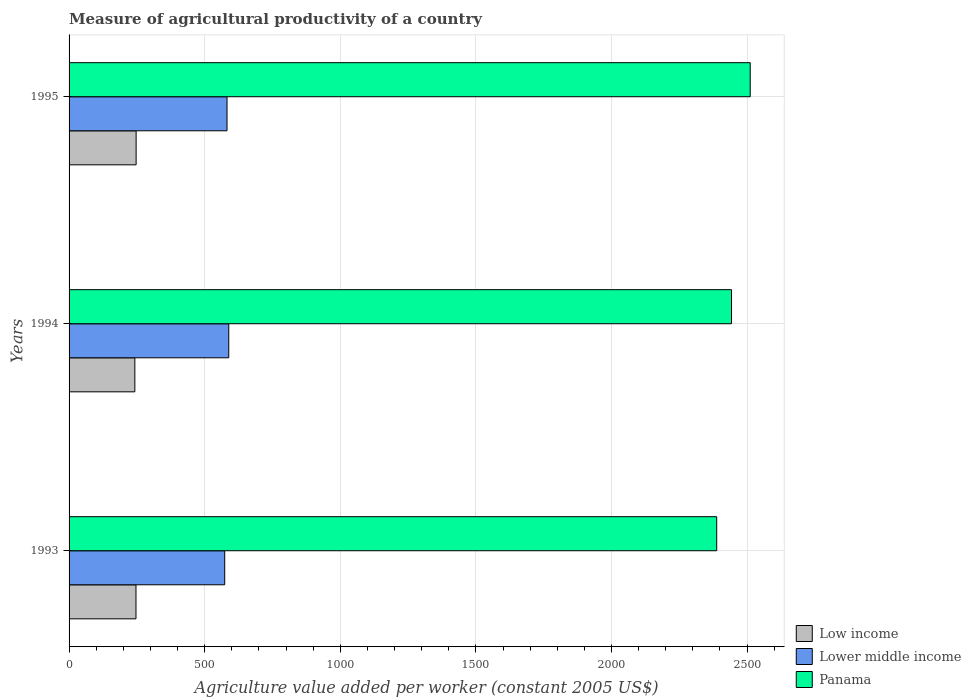How many groups of bars are there?
Provide a short and direct response. 3. Are the number of bars on each tick of the Y-axis equal?
Your answer should be very brief. Yes. How many bars are there on the 2nd tick from the bottom?
Your answer should be compact. 3. What is the label of the 2nd group of bars from the top?
Your response must be concise. 1994. What is the measure of agricultural productivity in Low income in 1994?
Offer a terse response. 242.52. Across all years, what is the maximum measure of agricultural productivity in Panama?
Keep it short and to the point. 2511.51. Across all years, what is the minimum measure of agricultural productivity in Low income?
Ensure brevity in your answer.  242.52. In which year was the measure of agricultural productivity in Panama minimum?
Ensure brevity in your answer.  1993. What is the total measure of agricultural productivity in Lower middle income in the graph?
Your response must be concise. 1745.16. What is the difference between the measure of agricultural productivity in Low income in 1994 and that in 1995?
Ensure brevity in your answer.  -4.74. What is the difference between the measure of agricultural productivity in Lower middle income in 1993 and the measure of agricultural productivity in Low income in 1994?
Your answer should be compact. 331.39. What is the average measure of agricultural productivity in Lower middle income per year?
Your response must be concise. 581.72. In the year 1993, what is the difference between the measure of agricultural productivity in Lower middle income and measure of agricultural productivity in Low income?
Offer a terse response. 327.18. What is the ratio of the measure of agricultural productivity in Low income in 1994 to that in 1995?
Keep it short and to the point. 0.98. Is the measure of agricultural productivity in Panama in 1994 less than that in 1995?
Offer a very short reply. Yes. Is the difference between the measure of agricultural productivity in Lower middle income in 1993 and 1995 greater than the difference between the measure of agricultural productivity in Low income in 1993 and 1995?
Your answer should be very brief. No. What is the difference between the highest and the second highest measure of agricultural productivity in Low income?
Keep it short and to the point. 0.53. What is the difference between the highest and the lowest measure of agricultural productivity in Low income?
Your response must be concise. 4.74. What does the 2nd bar from the top in 1994 represents?
Provide a short and direct response. Lower middle income. Is it the case that in every year, the sum of the measure of agricultural productivity in Lower middle income and measure of agricultural productivity in Low income is greater than the measure of agricultural productivity in Panama?
Keep it short and to the point. No. How many bars are there?
Make the answer very short. 9. How many years are there in the graph?
Your answer should be compact. 3. What is the difference between two consecutive major ticks on the X-axis?
Offer a terse response. 500. Does the graph contain any zero values?
Your response must be concise. No. Does the graph contain grids?
Your answer should be compact. Yes. Where does the legend appear in the graph?
Your answer should be very brief. Bottom right. How many legend labels are there?
Offer a very short reply. 3. What is the title of the graph?
Offer a terse response. Measure of agricultural productivity of a country. What is the label or title of the X-axis?
Offer a very short reply. Agriculture value added per worker (constant 2005 US$). What is the label or title of the Y-axis?
Offer a very short reply. Years. What is the Agriculture value added per worker (constant 2005 US$) of Low income in 1993?
Provide a succinct answer. 246.73. What is the Agriculture value added per worker (constant 2005 US$) in Lower middle income in 1993?
Offer a terse response. 573.91. What is the Agriculture value added per worker (constant 2005 US$) in Panama in 1993?
Offer a very short reply. 2387.97. What is the Agriculture value added per worker (constant 2005 US$) in Low income in 1994?
Provide a short and direct response. 242.52. What is the Agriculture value added per worker (constant 2005 US$) in Lower middle income in 1994?
Your answer should be compact. 588.82. What is the Agriculture value added per worker (constant 2005 US$) of Panama in 1994?
Make the answer very short. 2442.55. What is the Agriculture value added per worker (constant 2005 US$) of Low income in 1995?
Your answer should be compact. 247.26. What is the Agriculture value added per worker (constant 2005 US$) of Lower middle income in 1995?
Your answer should be compact. 582.44. What is the Agriculture value added per worker (constant 2005 US$) in Panama in 1995?
Provide a short and direct response. 2511.51. Across all years, what is the maximum Agriculture value added per worker (constant 2005 US$) in Low income?
Keep it short and to the point. 247.26. Across all years, what is the maximum Agriculture value added per worker (constant 2005 US$) of Lower middle income?
Ensure brevity in your answer.  588.82. Across all years, what is the maximum Agriculture value added per worker (constant 2005 US$) in Panama?
Your answer should be very brief. 2511.51. Across all years, what is the minimum Agriculture value added per worker (constant 2005 US$) of Low income?
Keep it short and to the point. 242.52. Across all years, what is the minimum Agriculture value added per worker (constant 2005 US$) in Lower middle income?
Offer a terse response. 573.91. Across all years, what is the minimum Agriculture value added per worker (constant 2005 US$) in Panama?
Ensure brevity in your answer.  2387.97. What is the total Agriculture value added per worker (constant 2005 US$) of Low income in the graph?
Your response must be concise. 736.5. What is the total Agriculture value added per worker (constant 2005 US$) of Lower middle income in the graph?
Keep it short and to the point. 1745.16. What is the total Agriculture value added per worker (constant 2005 US$) in Panama in the graph?
Provide a short and direct response. 7342.03. What is the difference between the Agriculture value added per worker (constant 2005 US$) in Low income in 1993 and that in 1994?
Offer a terse response. 4.21. What is the difference between the Agriculture value added per worker (constant 2005 US$) of Lower middle income in 1993 and that in 1994?
Offer a very short reply. -14.91. What is the difference between the Agriculture value added per worker (constant 2005 US$) of Panama in 1993 and that in 1994?
Give a very brief answer. -54.58. What is the difference between the Agriculture value added per worker (constant 2005 US$) in Low income in 1993 and that in 1995?
Provide a short and direct response. -0.53. What is the difference between the Agriculture value added per worker (constant 2005 US$) of Lower middle income in 1993 and that in 1995?
Ensure brevity in your answer.  -8.53. What is the difference between the Agriculture value added per worker (constant 2005 US$) in Panama in 1993 and that in 1995?
Offer a very short reply. -123.54. What is the difference between the Agriculture value added per worker (constant 2005 US$) of Low income in 1994 and that in 1995?
Ensure brevity in your answer.  -4.74. What is the difference between the Agriculture value added per worker (constant 2005 US$) of Lower middle income in 1994 and that in 1995?
Make the answer very short. 6.38. What is the difference between the Agriculture value added per worker (constant 2005 US$) of Panama in 1994 and that in 1995?
Give a very brief answer. -68.96. What is the difference between the Agriculture value added per worker (constant 2005 US$) of Low income in 1993 and the Agriculture value added per worker (constant 2005 US$) of Lower middle income in 1994?
Your response must be concise. -342.09. What is the difference between the Agriculture value added per worker (constant 2005 US$) of Low income in 1993 and the Agriculture value added per worker (constant 2005 US$) of Panama in 1994?
Provide a succinct answer. -2195.83. What is the difference between the Agriculture value added per worker (constant 2005 US$) in Lower middle income in 1993 and the Agriculture value added per worker (constant 2005 US$) in Panama in 1994?
Your answer should be compact. -1868.65. What is the difference between the Agriculture value added per worker (constant 2005 US$) in Low income in 1993 and the Agriculture value added per worker (constant 2005 US$) in Lower middle income in 1995?
Offer a terse response. -335.71. What is the difference between the Agriculture value added per worker (constant 2005 US$) in Low income in 1993 and the Agriculture value added per worker (constant 2005 US$) in Panama in 1995?
Provide a short and direct response. -2264.78. What is the difference between the Agriculture value added per worker (constant 2005 US$) in Lower middle income in 1993 and the Agriculture value added per worker (constant 2005 US$) in Panama in 1995?
Provide a succinct answer. -1937.6. What is the difference between the Agriculture value added per worker (constant 2005 US$) of Low income in 1994 and the Agriculture value added per worker (constant 2005 US$) of Lower middle income in 1995?
Make the answer very short. -339.92. What is the difference between the Agriculture value added per worker (constant 2005 US$) of Low income in 1994 and the Agriculture value added per worker (constant 2005 US$) of Panama in 1995?
Ensure brevity in your answer.  -2268.99. What is the difference between the Agriculture value added per worker (constant 2005 US$) in Lower middle income in 1994 and the Agriculture value added per worker (constant 2005 US$) in Panama in 1995?
Your response must be concise. -1922.69. What is the average Agriculture value added per worker (constant 2005 US$) of Low income per year?
Offer a very short reply. 245.5. What is the average Agriculture value added per worker (constant 2005 US$) of Lower middle income per year?
Your response must be concise. 581.72. What is the average Agriculture value added per worker (constant 2005 US$) in Panama per year?
Your answer should be very brief. 2447.34. In the year 1993, what is the difference between the Agriculture value added per worker (constant 2005 US$) in Low income and Agriculture value added per worker (constant 2005 US$) in Lower middle income?
Make the answer very short. -327.18. In the year 1993, what is the difference between the Agriculture value added per worker (constant 2005 US$) in Low income and Agriculture value added per worker (constant 2005 US$) in Panama?
Provide a short and direct response. -2141.24. In the year 1993, what is the difference between the Agriculture value added per worker (constant 2005 US$) of Lower middle income and Agriculture value added per worker (constant 2005 US$) of Panama?
Your answer should be compact. -1814.07. In the year 1994, what is the difference between the Agriculture value added per worker (constant 2005 US$) in Low income and Agriculture value added per worker (constant 2005 US$) in Lower middle income?
Offer a terse response. -346.3. In the year 1994, what is the difference between the Agriculture value added per worker (constant 2005 US$) of Low income and Agriculture value added per worker (constant 2005 US$) of Panama?
Offer a terse response. -2200.04. In the year 1994, what is the difference between the Agriculture value added per worker (constant 2005 US$) in Lower middle income and Agriculture value added per worker (constant 2005 US$) in Panama?
Provide a succinct answer. -1853.74. In the year 1995, what is the difference between the Agriculture value added per worker (constant 2005 US$) of Low income and Agriculture value added per worker (constant 2005 US$) of Lower middle income?
Ensure brevity in your answer.  -335.18. In the year 1995, what is the difference between the Agriculture value added per worker (constant 2005 US$) of Low income and Agriculture value added per worker (constant 2005 US$) of Panama?
Your response must be concise. -2264.25. In the year 1995, what is the difference between the Agriculture value added per worker (constant 2005 US$) in Lower middle income and Agriculture value added per worker (constant 2005 US$) in Panama?
Make the answer very short. -1929.07. What is the ratio of the Agriculture value added per worker (constant 2005 US$) in Low income in 1993 to that in 1994?
Offer a terse response. 1.02. What is the ratio of the Agriculture value added per worker (constant 2005 US$) in Lower middle income in 1993 to that in 1994?
Your response must be concise. 0.97. What is the ratio of the Agriculture value added per worker (constant 2005 US$) of Panama in 1993 to that in 1994?
Ensure brevity in your answer.  0.98. What is the ratio of the Agriculture value added per worker (constant 2005 US$) in Lower middle income in 1993 to that in 1995?
Provide a succinct answer. 0.99. What is the ratio of the Agriculture value added per worker (constant 2005 US$) of Panama in 1993 to that in 1995?
Keep it short and to the point. 0.95. What is the ratio of the Agriculture value added per worker (constant 2005 US$) in Low income in 1994 to that in 1995?
Give a very brief answer. 0.98. What is the ratio of the Agriculture value added per worker (constant 2005 US$) of Panama in 1994 to that in 1995?
Offer a terse response. 0.97. What is the difference between the highest and the second highest Agriculture value added per worker (constant 2005 US$) of Low income?
Your response must be concise. 0.53. What is the difference between the highest and the second highest Agriculture value added per worker (constant 2005 US$) of Lower middle income?
Give a very brief answer. 6.38. What is the difference between the highest and the second highest Agriculture value added per worker (constant 2005 US$) of Panama?
Give a very brief answer. 68.96. What is the difference between the highest and the lowest Agriculture value added per worker (constant 2005 US$) in Low income?
Ensure brevity in your answer.  4.74. What is the difference between the highest and the lowest Agriculture value added per worker (constant 2005 US$) in Lower middle income?
Your response must be concise. 14.91. What is the difference between the highest and the lowest Agriculture value added per worker (constant 2005 US$) of Panama?
Your answer should be compact. 123.54. 